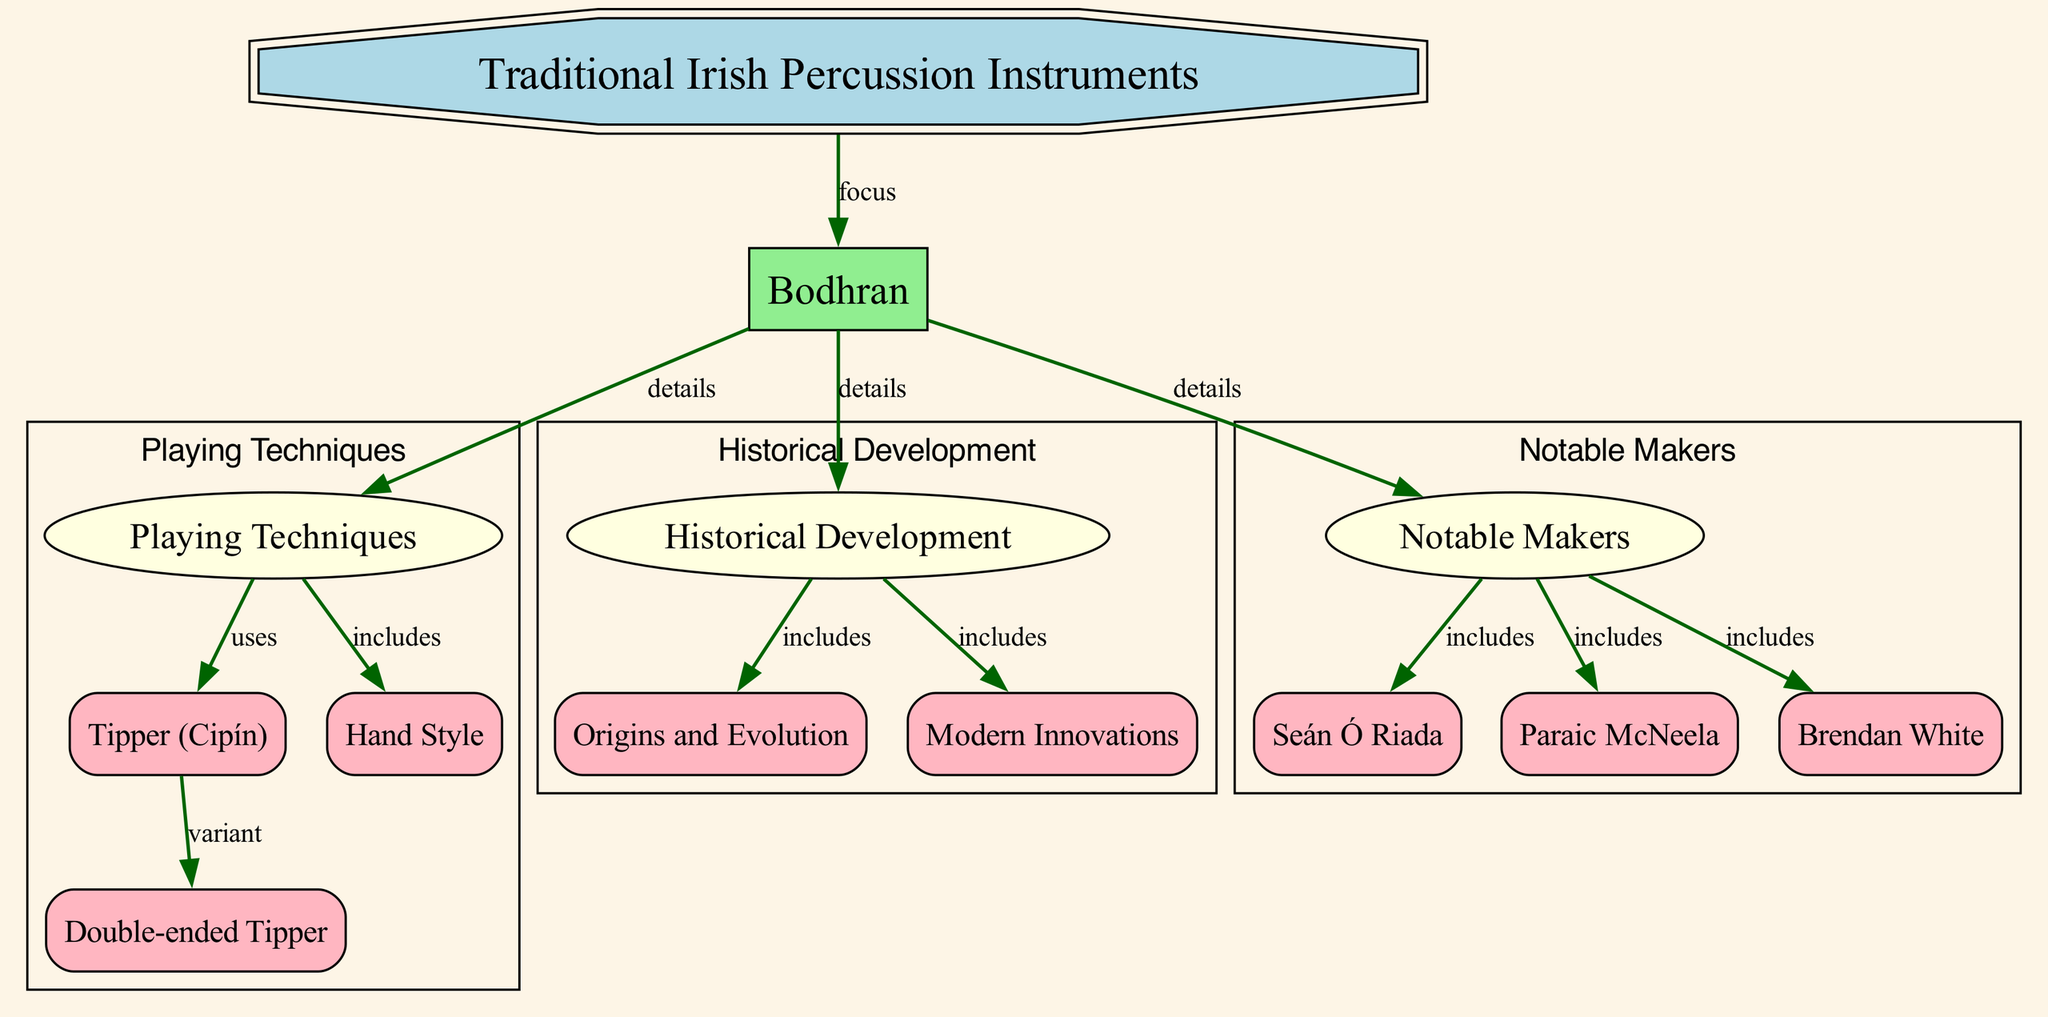What is the main focus of the diagram? The diagram centers around Traditional Irish Percussion Instruments, which is indicated by the first node labeled "Traditional Irish Percussion Instruments."
Answer: Traditional Irish Percussion Instruments How many notable makers are listed in the diagram? There are three notable makers specifically highlighted in the diagram, denoted by the edges connecting the "Notable Makers" node to the individual makers' nodes.
Answer: 3 Which playing technique includes the use of a double-ended tipper? The "Playing Techniques" node specifically connects to "Tipper (Cipín)," which further connects to "Double-ended Tipper," indicating that this variant is a method associated with a tipper.
Answer: Double-ended Tipper What is included in the historical development of the bodhran? The "Historical Development" node connects to "Origins and Evolution" and "Modern Innovations," showing these two concepts are part of the bodhran's history.
Answer: Origins and Evolution, Modern Innovations What type of shape represents the bodhran node in the diagram? The bodhran node is represented as a box shape, which distinguishes it from other shapes used in the diagram.
Answer: Box Which technique is a variant of the tipper? The relationship indicated in the diagram shows that the "Double-ended Tipper" is a variant of the "Tipper (Cipín)."
Answer: Double-ended Tipper Who is one of the notable makers of the bodhran indicated in the diagram? The diagram lists Seán Ó Riada as one of the notable makers connected to the "Notable Makers" node.
Answer: Seán Ó Riada What does the edge labeled "details" imply about the relationships in the diagram? The "details" label on the edges indicates that the subsequent nodes provide additional specific information related to the "Bodhran" node, implying a deeper exploration of the topic.
Answer: Details What playing technique is associated with hand use? The diagram connects the "Playing Techniques" node directly to the "Hand Style," indicating that this technique involves hand performance.
Answer: Hand Style 